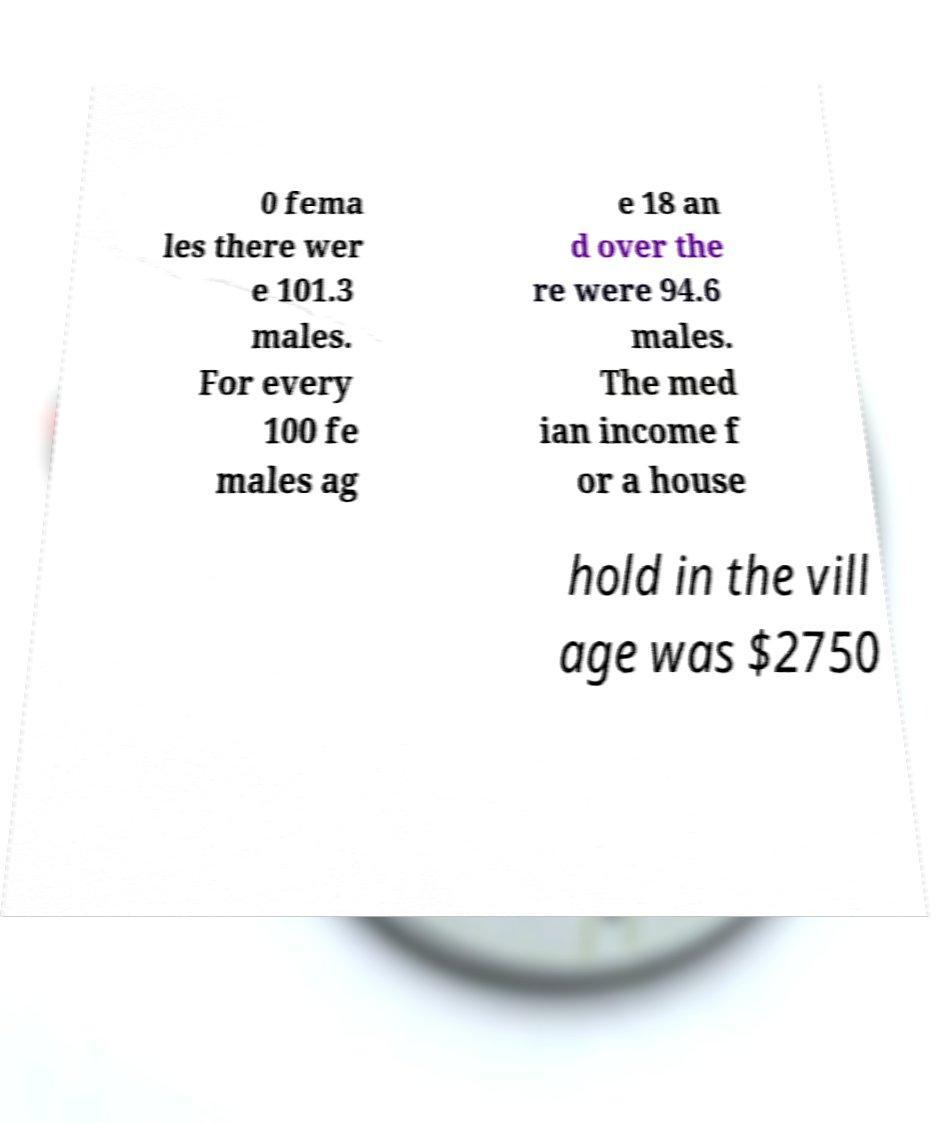Please read and relay the text visible in this image. What does it say? 0 fema les there wer e 101.3 males. For every 100 fe males ag e 18 an d over the re were 94.6 males. The med ian income f or a house hold in the vill age was $2750 